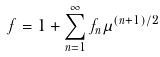Convert formula to latex. <formula><loc_0><loc_0><loc_500><loc_500>f = 1 + \sum _ { n = 1 } ^ { \infty } f _ { n } \mu ^ { ( n + 1 ) / 2 }</formula> 